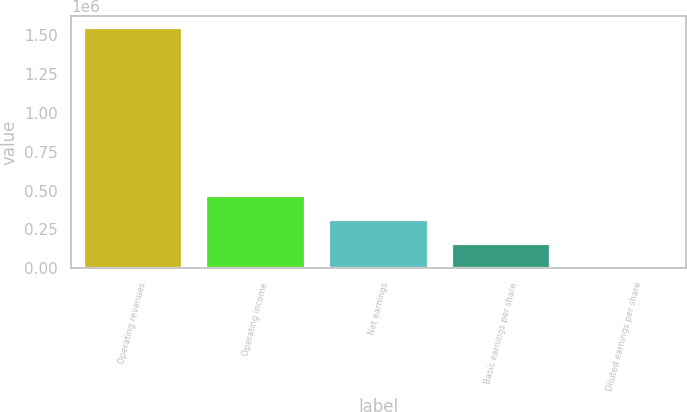Convert chart to OTSL. <chart><loc_0><loc_0><loc_500><loc_500><bar_chart><fcel>Operating revenues<fcel>Operating income<fcel>Net earnings<fcel>Basic earnings per share<fcel>Diluted earnings per share<nl><fcel>1.54787e+06<fcel>464361<fcel>309574<fcel>154787<fcel>0.79<nl></chart> 